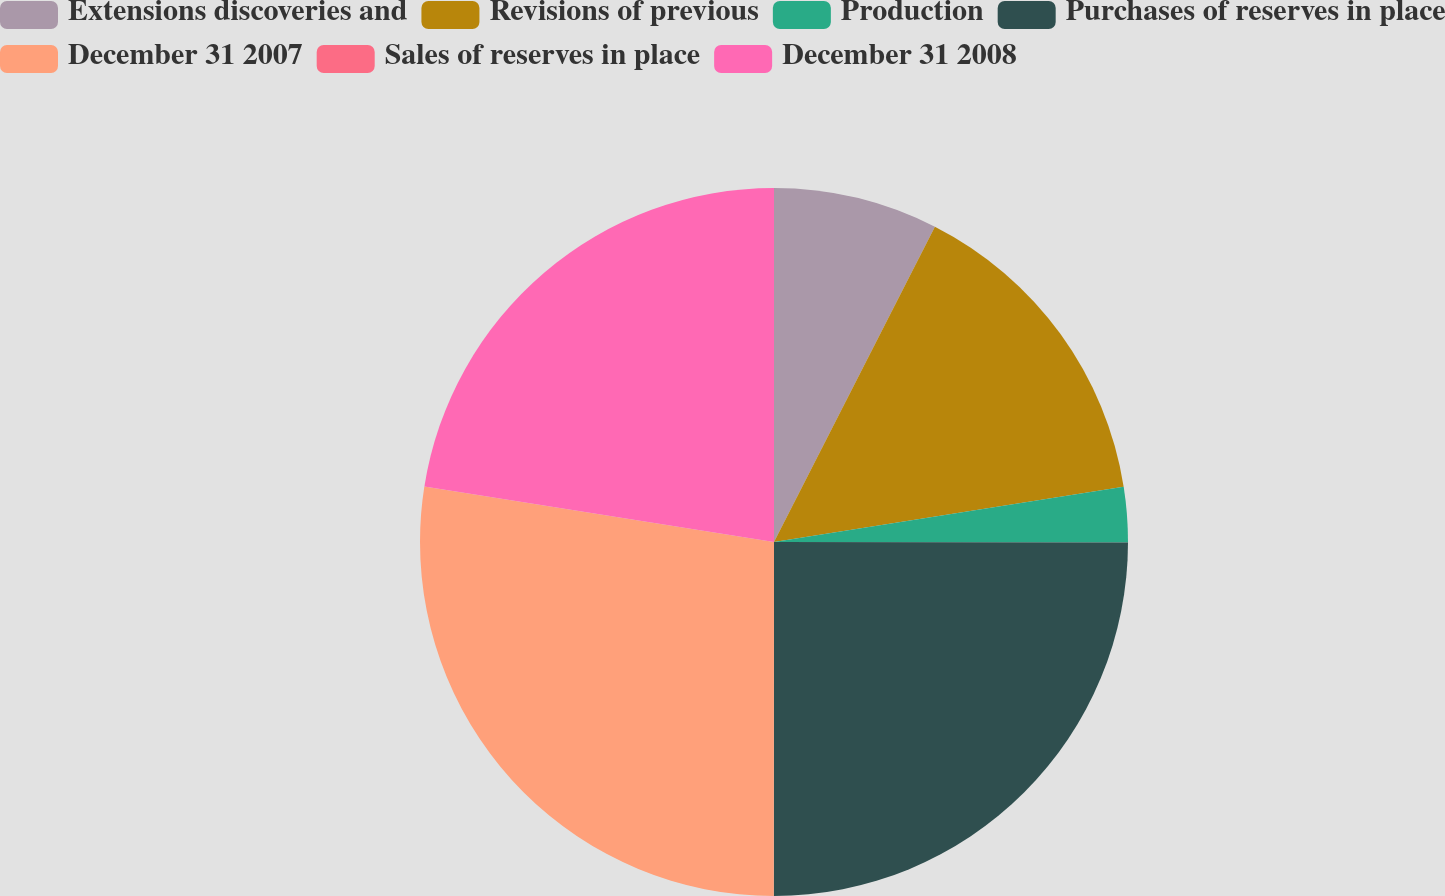Convert chart. <chart><loc_0><loc_0><loc_500><loc_500><pie_chart><fcel>Extensions discoveries and<fcel>Revisions of previous<fcel>Production<fcel>Purchases of reserves in place<fcel>December 31 2007<fcel>Sales of reserves in place<fcel>December 31 2008<nl><fcel>7.51%<fcel>15.0%<fcel>2.51%<fcel>24.99%<fcel>27.49%<fcel>0.01%<fcel>22.49%<nl></chart> 